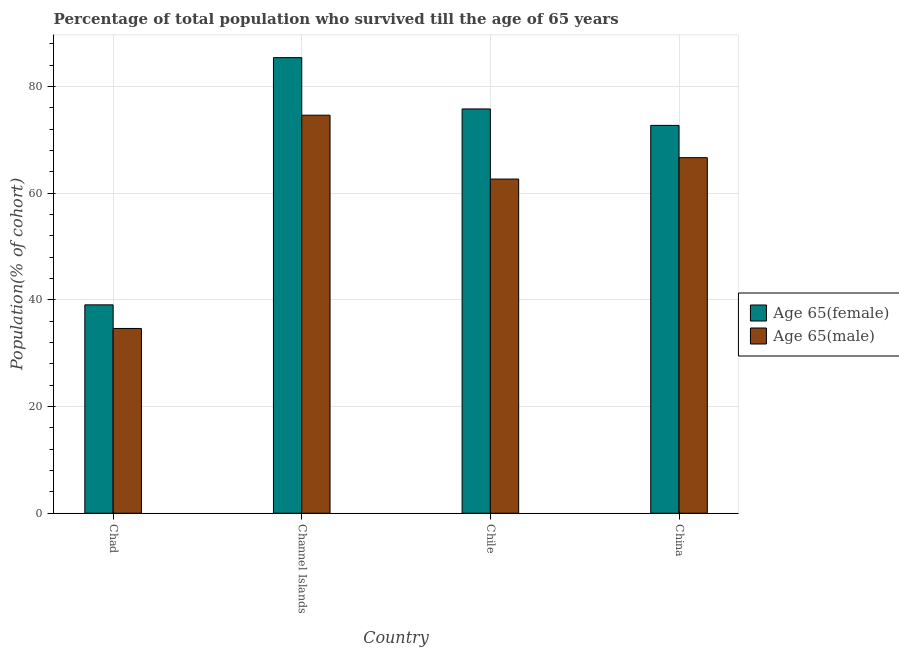Are the number of bars on each tick of the X-axis equal?
Provide a succinct answer. Yes. How many bars are there on the 4th tick from the right?
Your response must be concise. 2. What is the label of the 2nd group of bars from the left?
Your answer should be very brief. Channel Islands. What is the percentage of female population who survived till age of 65 in China?
Provide a short and direct response. 72.73. Across all countries, what is the maximum percentage of male population who survived till age of 65?
Keep it short and to the point. 74.64. Across all countries, what is the minimum percentage of female population who survived till age of 65?
Your response must be concise. 39.07. In which country was the percentage of female population who survived till age of 65 maximum?
Your answer should be compact. Channel Islands. In which country was the percentage of female population who survived till age of 65 minimum?
Ensure brevity in your answer.  Chad. What is the total percentage of female population who survived till age of 65 in the graph?
Offer a very short reply. 273.04. What is the difference between the percentage of male population who survived till age of 65 in Channel Islands and that in China?
Offer a very short reply. 7.96. What is the difference between the percentage of female population who survived till age of 65 in Chile and the percentage of male population who survived till age of 65 in Channel Islands?
Offer a terse response. 1.17. What is the average percentage of male population who survived till age of 65 per country?
Offer a very short reply. 59.66. What is the difference between the percentage of male population who survived till age of 65 and percentage of female population who survived till age of 65 in China?
Ensure brevity in your answer.  -6.05. In how many countries, is the percentage of female population who survived till age of 65 greater than 84 %?
Provide a succinct answer. 1. What is the ratio of the percentage of female population who survived till age of 65 in Chad to that in Chile?
Keep it short and to the point. 0.52. What is the difference between the highest and the second highest percentage of female population who survived till age of 65?
Provide a succinct answer. 9.62. What is the difference between the highest and the lowest percentage of female population who survived till age of 65?
Your response must be concise. 46.36. In how many countries, is the percentage of female population who survived till age of 65 greater than the average percentage of female population who survived till age of 65 taken over all countries?
Keep it short and to the point. 3. Is the sum of the percentage of female population who survived till age of 65 in Chad and Chile greater than the maximum percentage of male population who survived till age of 65 across all countries?
Ensure brevity in your answer.  Yes. What does the 2nd bar from the left in Channel Islands represents?
Ensure brevity in your answer.  Age 65(male). What does the 1st bar from the right in China represents?
Ensure brevity in your answer.  Age 65(male). Are all the bars in the graph horizontal?
Offer a very short reply. No. What is the difference between two consecutive major ticks on the Y-axis?
Ensure brevity in your answer.  20. Where does the legend appear in the graph?
Offer a very short reply. Center right. How many legend labels are there?
Your answer should be compact. 2. What is the title of the graph?
Provide a succinct answer. Percentage of total population who survived till the age of 65 years. Does "Working capital" appear as one of the legend labels in the graph?
Ensure brevity in your answer.  No. What is the label or title of the X-axis?
Provide a short and direct response. Country. What is the label or title of the Y-axis?
Your answer should be compact. Population(% of cohort). What is the Population(% of cohort) in Age 65(female) in Chad?
Your response must be concise. 39.07. What is the Population(% of cohort) in Age 65(male) in Chad?
Provide a succinct answer. 34.65. What is the Population(% of cohort) in Age 65(female) in Channel Islands?
Your response must be concise. 85.43. What is the Population(% of cohort) of Age 65(male) in Channel Islands?
Ensure brevity in your answer.  74.64. What is the Population(% of cohort) in Age 65(female) in Chile?
Provide a short and direct response. 75.81. What is the Population(% of cohort) in Age 65(male) in Chile?
Ensure brevity in your answer.  62.66. What is the Population(% of cohort) in Age 65(female) in China?
Your answer should be very brief. 72.73. What is the Population(% of cohort) in Age 65(male) in China?
Offer a terse response. 66.68. Across all countries, what is the maximum Population(% of cohort) in Age 65(female)?
Your answer should be compact. 85.43. Across all countries, what is the maximum Population(% of cohort) of Age 65(male)?
Provide a short and direct response. 74.64. Across all countries, what is the minimum Population(% of cohort) of Age 65(female)?
Keep it short and to the point. 39.07. Across all countries, what is the minimum Population(% of cohort) of Age 65(male)?
Your answer should be compact. 34.65. What is the total Population(% of cohort) of Age 65(female) in the graph?
Make the answer very short. 273.04. What is the total Population(% of cohort) in Age 65(male) in the graph?
Make the answer very short. 238.62. What is the difference between the Population(% of cohort) in Age 65(female) in Chad and that in Channel Islands?
Offer a terse response. -46.36. What is the difference between the Population(% of cohort) of Age 65(male) in Chad and that in Channel Islands?
Ensure brevity in your answer.  -39.99. What is the difference between the Population(% of cohort) in Age 65(female) in Chad and that in Chile?
Your answer should be compact. -36.74. What is the difference between the Population(% of cohort) of Age 65(male) in Chad and that in Chile?
Provide a short and direct response. -28.02. What is the difference between the Population(% of cohort) of Age 65(female) in Chad and that in China?
Provide a short and direct response. -33.66. What is the difference between the Population(% of cohort) in Age 65(male) in Chad and that in China?
Keep it short and to the point. -32.03. What is the difference between the Population(% of cohort) in Age 65(female) in Channel Islands and that in Chile?
Make the answer very short. 9.62. What is the difference between the Population(% of cohort) of Age 65(male) in Channel Islands and that in Chile?
Make the answer very short. 11.97. What is the difference between the Population(% of cohort) of Age 65(female) in Channel Islands and that in China?
Provide a succinct answer. 12.7. What is the difference between the Population(% of cohort) of Age 65(male) in Channel Islands and that in China?
Your response must be concise. 7.96. What is the difference between the Population(% of cohort) of Age 65(female) in Chile and that in China?
Ensure brevity in your answer.  3.08. What is the difference between the Population(% of cohort) of Age 65(male) in Chile and that in China?
Give a very brief answer. -4.01. What is the difference between the Population(% of cohort) of Age 65(female) in Chad and the Population(% of cohort) of Age 65(male) in Channel Islands?
Make the answer very short. -35.57. What is the difference between the Population(% of cohort) of Age 65(female) in Chad and the Population(% of cohort) of Age 65(male) in Chile?
Your answer should be compact. -23.59. What is the difference between the Population(% of cohort) of Age 65(female) in Chad and the Population(% of cohort) of Age 65(male) in China?
Give a very brief answer. -27.6. What is the difference between the Population(% of cohort) of Age 65(female) in Channel Islands and the Population(% of cohort) of Age 65(male) in Chile?
Ensure brevity in your answer.  22.77. What is the difference between the Population(% of cohort) of Age 65(female) in Channel Islands and the Population(% of cohort) of Age 65(male) in China?
Your answer should be very brief. 18.75. What is the difference between the Population(% of cohort) in Age 65(female) in Chile and the Population(% of cohort) in Age 65(male) in China?
Offer a terse response. 9.14. What is the average Population(% of cohort) in Age 65(female) per country?
Offer a very short reply. 68.26. What is the average Population(% of cohort) of Age 65(male) per country?
Your response must be concise. 59.66. What is the difference between the Population(% of cohort) of Age 65(female) and Population(% of cohort) of Age 65(male) in Chad?
Your answer should be very brief. 4.43. What is the difference between the Population(% of cohort) in Age 65(female) and Population(% of cohort) in Age 65(male) in Channel Islands?
Your response must be concise. 10.79. What is the difference between the Population(% of cohort) of Age 65(female) and Population(% of cohort) of Age 65(male) in Chile?
Your answer should be compact. 13.15. What is the difference between the Population(% of cohort) of Age 65(female) and Population(% of cohort) of Age 65(male) in China?
Your answer should be compact. 6.05. What is the ratio of the Population(% of cohort) of Age 65(female) in Chad to that in Channel Islands?
Provide a short and direct response. 0.46. What is the ratio of the Population(% of cohort) of Age 65(male) in Chad to that in Channel Islands?
Keep it short and to the point. 0.46. What is the ratio of the Population(% of cohort) in Age 65(female) in Chad to that in Chile?
Offer a very short reply. 0.52. What is the ratio of the Population(% of cohort) in Age 65(male) in Chad to that in Chile?
Make the answer very short. 0.55. What is the ratio of the Population(% of cohort) in Age 65(female) in Chad to that in China?
Your response must be concise. 0.54. What is the ratio of the Population(% of cohort) in Age 65(male) in Chad to that in China?
Offer a terse response. 0.52. What is the ratio of the Population(% of cohort) of Age 65(female) in Channel Islands to that in Chile?
Your response must be concise. 1.13. What is the ratio of the Population(% of cohort) of Age 65(male) in Channel Islands to that in Chile?
Make the answer very short. 1.19. What is the ratio of the Population(% of cohort) of Age 65(female) in Channel Islands to that in China?
Your response must be concise. 1.17. What is the ratio of the Population(% of cohort) in Age 65(male) in Channel Islands to that in China?
Provide a succinct answer. 1.12. What is the ratio of the Population(% of cohort) in Age 65(female) in Chile to that in China?
Give a very brief answer. 1.04. What is the ratio of the Population(% of cohort) in Age 65(male) in Chile to that in China?
Provide a succinct answer. 0.94. What is the difference between the highest and the second highest Population(% of cohort) of Age 65(female)?
Provide a short and direct response. 9.62. What is the difference between the highest and the second highest Population(% of cohort) of Age 65(male)?
Your answer should be very brief. 7.96. What is the difference between the highest and the lowest Population(% of cohort) of Age 65(female)?
Give a very brief answer. 46.36. What is the difference between the highest and the lowest Population(% of cohort) of Age 65(male)?
Provide a short and direct response. 39.99. 